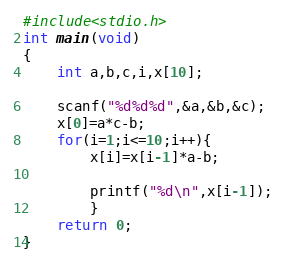Convert code to text. <code><loc_0><loc_0><loc_500><loc_500><_C_>#include<stdio.h>
int main(void)
{
	int a,b,c,i,x[10];

	scanf("%d%d%d",&a,&b,&c);
	x[0]=a*c-b;
	for(i=1;i<=10;i++){
		x[i]=x[i-1]*a-b;
		
		printf("%d\n",x[i-1]);
		}
	return 0;
}

</code> 